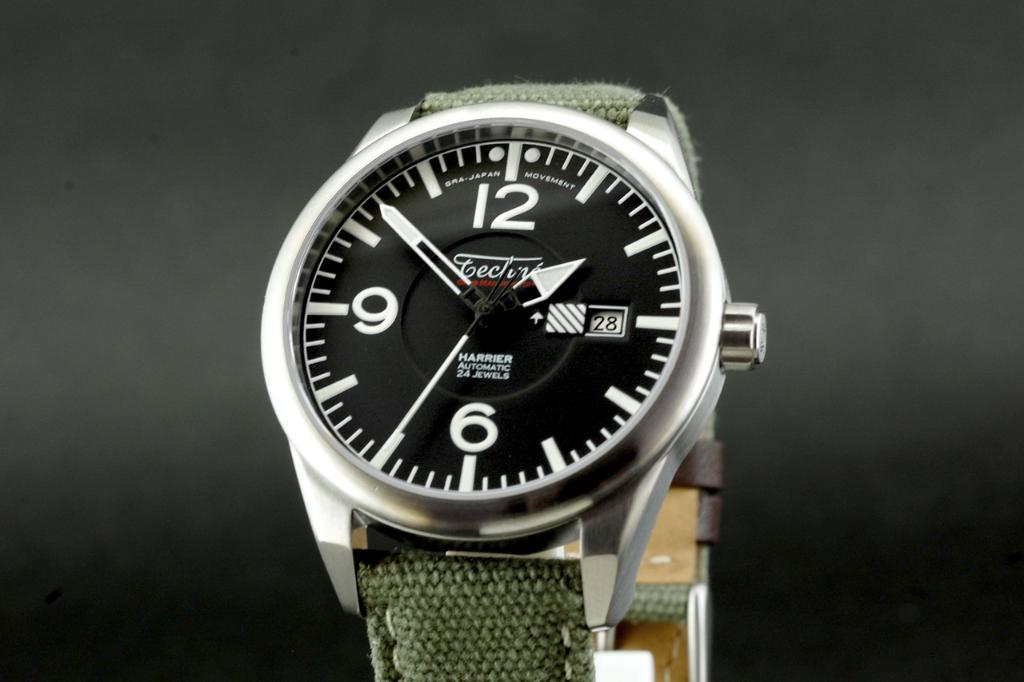<image>
Present a compact description of the photo's key features. A watch has only numbers 12,6, and 9 visible. 